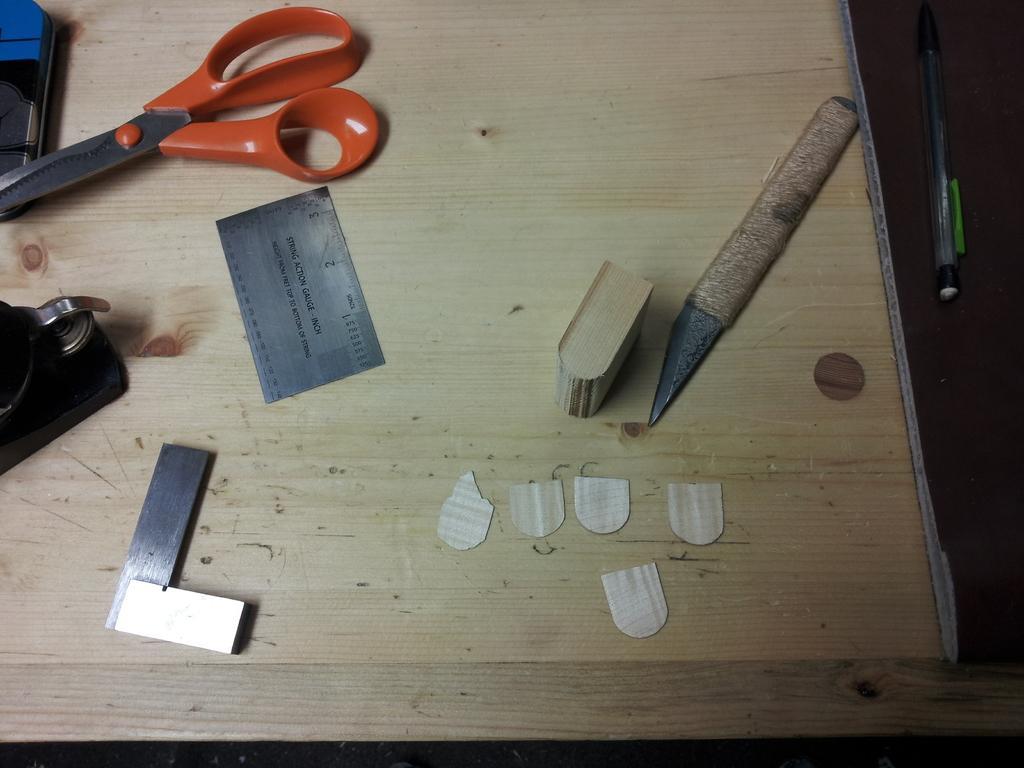Describe this image in one or two sentences. In this image I can see some objects. In the background, I can see the table. 